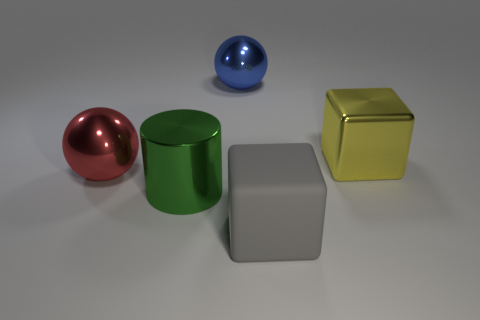Add 2 large gray rubber blocks. How many objects exist? 7 Subtract all spheres. How many objects are left? 3 Add 1 large green cylinders. How many large green cylinders exist? 2 Subtract 0 brown cylinders. How many objects are left? 5 Subtract all large green shiny cylinders. Subtract all blue balls. How many objects are left? 3 Add 1 large blocks. How many large blocks are left? 3 